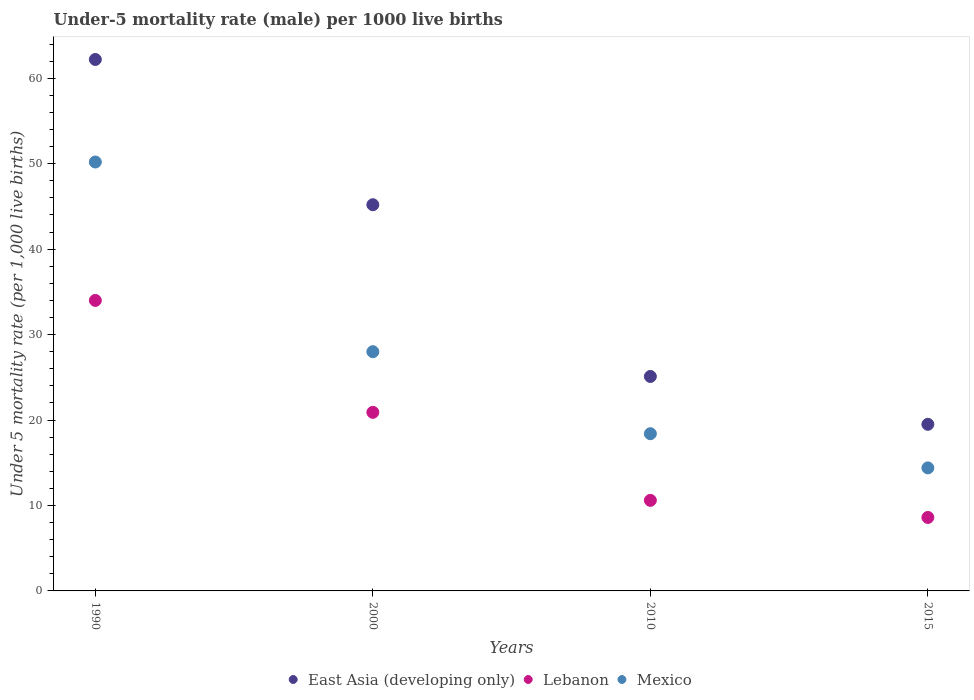Across all years, what is the maximum under-five mortality rate in Mexico?
Your answer should be compact. 50.2. Across all years, what is the minimum under-five mortality rate in Mexico?
Offer a terse response. 14.4. In which year was the under-five mortality rate in Lebanon minimum?
Ensure brevity in your answer.  2015. What is the total under-five mortality rate in Lebanon in the graph?
Keep it short and to the point. 74.1. What is the difference between the under-five mortality rate in East Asia (developing only) in 1990 and that in 2010?
Your answer should be very brief. 37.1. What is the difference between the under-five mortality rate in Mexico in 2000 and the under-five mortality rate in Lebanon in 2010?
Provide a short and direct response. 17.4. What is the average under-five mortality rate in Lebanon per year?
Make the answer very short. 18.52. In the year 2015, what is the difference between the under-five mortality rate in Mexico and under-five mortality rate in Lebanon?
Offer a terse response. 5.8. In how many years, is the under-five mortality rate in Lebanon greater than 56?
Give a very brief answer. 0. What is the ratio of the under-five mortality rate in Lebanon in 1990 to that in 2015?
Give a very brief answer. 3.95. Is the under-five mortality rate in Lebanon in 2000 less than that in 2015?
Keep it short and to the point. No. What is the difference between the highest and the second highest under-five mortality rate in East Asia (developing only)?
Your answer should be very brief. 17. What is the difference between the highest and the lowest under-five mortality rate in East Asia (developing only)?
Provide a short and direct response. 42.7. Is it the case that in every year, the sum of the under-five mortality rate in Lebanon and under-five mortality rate in Mexico  is greater than the under-five mortality rate in East Asia (developing only)?
Your answer should be very brief. Yes. What is the difference between two consecutive major ticks on the Y-axis?
Your answer should be compact. 10. Are the values on the major ticks of Y-axis written in scientific E-notation?
Give a very brief answer. No. Does the graph contain grids?
Keep it short and to the point. No. How many legend labels are there?
Make the answer very short. 3. What is the title of the graph?
Your answer should be very brief. Under-5 mortality rate (male) per 1000 live births. What is the label or title of the Y-axis?
Offer a terse response. Under 5 mortality rate (per 1,0 live births). What is the Under 5 mortality rate (per 1,000 live births) of East Asia (developing only) in 1990?
Make the answer very short. 62.2. What is the Under 5 mortality rate (per 1,000 live births) in Lebanon in 1990?
Your response must be concise. 34. What is the Under 5 mortality rate (per 1,000 live births) in Mexico in 1990?
Offer a very short reply. 50.2. What is the Under 5 mortality rate (per 1,000 live births) of East Asia (developing only) in 2000?
Offer a terse response. 45.2. What is the Under 5 mortality rate (per 1,000 live births) in Lebanon in 2000?
Offer a very short reply. 20.9. What is the Under 5 mortality rate (per 1,000 live births) in Mexico in 2000?
Make the answer very short. 28. What is the Under 5 mortality rate (per 1,000 live births) of East Asia (developing only) in 2010?
Your answer should be very brief. 25.1. What is the Under 5 mortality rate (per 1,000 live births) of Lebanon in 2010?
Your answer should be very brief. 10.6. What is the Under 5 mortality rate (per 1,000 live births) in Lebanon in 2015?
Your answer should be compact. 8.6. Across all years, what is the maximum Under 5 mortality rate (per 1,000 live births) in East Asia (developing only)?
Your response must be concise. 62.2. Across all years, what is the maximum Under 5 mortality rate (per 1,000 live births) in Lebanon?
Offer a terse response. 34. Across all years, what is the maximum Under 5 mortality rate (per 1,000 live births) of Mexico?
Your answer should be very brief. 50.2. Across all years, what is the minimum Under 5 mortality rate (per 1,000 live births) in East Asia (developing only)?
Your answer should be compact. 19.5. Across all years, what is the minimum Under 5 mortality rate (per 1,000 live births) of Lebanon?
Your answer should be compact. 8.6. What is the total Under 5 mortality rate (per 1,000 live births) of East Asia (developing only) in the graph?
Your answer should be compact. 152. What is the total Under 5 mortality rate (per 1,000 live births) in Lebanon in the graph?
Ensure brevity in your answer.  74.1. What is the total Under 5 mortality rate (per 1,000 live births) of Mexico in the graph?
Your answer should be very brief. 111. What is the difference between the Under 5 mortality rate (per 1,000 live births) of East Asia (developing only) in 1990 and that in 2000?
Offer a terse response. 17. What is the difference between the Under 5 mortality rate (per 1,000 live births) in Lebanon in 1990 and that in 2000?
Give a very brief answer. 13.1. What is the difference between the Under 5 mortality rate (per 1,000 live births) of East Asia (developing only) in 1990 and that in 2010?
Make the answer very short. 37.1. What is the difference between the Under 5 mortality rate (per 1,000 live births) of Lebanon in 1990 and that in 2010?
Your response must be concise. 23.4. What is the difference between the Under 5 mortality rate (per 1,000 live births) in Mexico in 1990 and that in 2010?
Your answer should be very brief. 31.8. What is the difference between the Under 5 mortality rate (per 1,000 live births) in East Asia (developing only) in 1990 and that in 2015?
Offer a terse response. 42.7. What is the difference between the Under 5 mortality rate (per 1,000 live births) of Lebanon in 1990 and that in 2015?
Provide a succinct answer. 25.4. What is the difference between the Under 5 mortality rate (per 1,000 live births) in Mexico in 1990 and that in 2015?
Ensure brevity in your answer.  35.8. What is the difference between the Under 5 mortality rate (per 1,000 live births) in East Asia (developing only) in 2000 and that in 2010?
Ensure brevity in your answer.  20.1. What is the difference between the Under 5 mortality rate (per 1,000 live births) in East Asia (developing only) in 2000 and that in 2015?
Offer a very short reply. 25.7. What is the difference between the Under 5 mortality rate (per 1,000 live births) of East Asia (developing only) in 2010 and that in 2015?
Give a very brief answer. 5.6. What is the difference between the Under 5 mortality rate (per 1,000 live births) in Lebanon in 2010 and that in 2015?
Your answer should be very brief. 2. What is the difference between the Under 5 mortality rate (per 1,000 live births) in Mexico in 2010 and that in 2015?
Offer a terse response. 4. What is the difference between the Under 5 mortality rate (per 1,000 live births) of East Asia (developing only) in 1990 and the Under 5 mortality rate (per 1,000 live births) of Lebanon in 2000?
Provide a short and direct response. 41.3. What is the difference between the Under 5 mortality rate (per 1,000 live births) in East Asia (developing only) in 1990 and the Under 5 mortality rate (per 1,000 live births) in Mexico in 2000?
Offer a terse response. 34.2. What is the difference between the Under 5 mortality rate (per 1,000 live births) in East Asia (developing only) in 1990 and the Under 5 mortality rate (per 1,000 live births) in Lebanon in 2010?
Ensure brevity in your answer.  51.6. What is the difference between the Under 5 mortality rate (per 1,000 live births) of East Asia (developing only) in 1990 and the Under 5 mortality rate (per 1,000 live births) of Mexico in 2010?
Keep it short and to the point. 43.8. What is the difference between the Under 5 mortality rate (per 1,000 live births) of East Asia (developing only) in 1990 and the Under 5 mortality rate (per 1,000 live births) of Lebanon in 2015?
Your answer should be compact. 53.6. What is the difference between the Under 5 mortality rate (per 1,000 live births) of East Asia (developing only) in 1990 and the Under 5 mortality rate (per 1,000 live births) of Mexico in 2015?
Your response must be concise. 47.8. What is the difference between the Under 5 mortality rate (per 1,000 live births) in Lebanon in 1990 and the Under 5 mortality rate (per 1,000 live births) in Mexico in 2015?
Your response must be concise. 19.6. What is the difference between the Under 5 mortality rate (per 1,000 live births) in East Asia (developing only) in 2000 and the Under 5 mortality rate (per 1,000 live births) in Lebanon in 2010?
Your answer should be very brief. 34.6. What is the difference between the Under 5 mortality rate (per 1,000 live births) of East Asia (developing only) in 2000 and the Under 5 mortality rate (per 1,000 live births) of Mexico in 2010?
Keep it short and to the point. 26.8. What is the difference between the Under 5 mortality rate (per 1,000 live births) in Lebanon in 2000 and the Under 5 mortality rate (per 1,000 live births) in Mexico in 2010?
Your answer should be compact. 2.5. What is the difference between the Under 5 mortality rate (per 1,000 live births) of East Asia (developing only) in 2000 and the Under 5 mortality rate (per 1,000 live births) of Lebanon in 2015?
Make the answer very short. 36.6. What is the difference between the Under 5 mortality rate (per 1,000 live births) in East Asia (developing only) in 2000 and the Under 5 mortality rate (per 1,000 live births) in Mexico in 2015?
Offer a terse response. 30.8. What is the average Under 5 mortality rate (per 1,000 live births) in East Asia (developing only) per year?
Provide a short and direct response. 38. What is the average Under 5 mortality rate (per 1,000 live births) in Lebanon per year?
Keep it short and to the point. 18.52. What is the average Under 5 mortality rate (per 1,000 live births) of Mexico per year?
Give a very brief answer. 27.75. In the year 1990, what is the difference between the Under 5 mortality rate (per 1,000 live births) in East Asia (developing only) and Under 5 mortality rate (per 1,000 live births) in Lebanon?
Your answer should be compact. 28.2. In the year 1990, what is the difference between the Under 5 mortality rate (per 1,000 live births) of East Asia (developing only) and Under 5 mortality rate (per 1,000 live births) of Mexico?
Make the answer very short. 12. In the year 1990, what is the difference between the Under 5 mortality rate (per 1,000 live births) of Lebanon and Under 5 mortality rate (per 1,000 live births) of Mexico?
Make the answer very short. -16.2. In the year 2000, what is the difference between the Under 5 mortality rate (per 1,000 live births) in East Asia (developing only) and Under 5 mortality rate (per 1,000 live births) in Lebanon?
Your response must be concise. 24.3. In the year 2010, what is the difference between the Under 5 mortality rate (per 1,000 live births) of East Asia (developing only) and Under 5 mortality rate (per 1,000 live births) of Lebanon?
Provide a short and direct response. 14.5. In the year 2010, what is the difference between the Under 5 mortality rate (per 1,000 live births) in East Asia (developing only) and Under 5 mortality rate (per 1,000 live births) in Mexico?
Your answer should be very brief. 6.7. In the year 2010, what is the difference between the Under 5 mortality rate (per 1,000 live births) in Lebanon and Under 5 mortality rate (per 1,000 live births) in Mexico?
Provide a short and direct response. -7.8. In the year 2015, what is the difference between the Under 5 mortality rate (per 1,000 live births) in East Asia (developing only) and Under 5 mortality rate (per 1,000 live births) in Mexico?
Make the answer very short. 5.1. What is the ratio of the Under 5 mortality rate (per 1,000 live births) of East Asia (developing only) in 1990 to that in 2000?
Offer a terse response. 1.38. What is the ratio of the Under 5 mortality rate (per 1,000 live births) in Lebanon in 1990 to that in 2000?
Keep it short and to the point. 1.63. What is the ratio of the Under 5 mortality rate (per 1,000 live births) in Mexico in 1990 to that in 2000?
Offer a terse response. 1.79. What is the ratio of the Under 5 mortality rate (per 1,000 live births) of East Asia (developing only) in 1990 to that in 2010?
Your answer should be compact. 2.48. What is the ratio of the Under 5 mortality rate (per 1,000 live births) in Lebanon in 1990 to that in 2010?
Ensure brevity in your answer.  3.21. What is the ratio of the Under 5 mortality rate (per 1,000 live births) in Mexico in 1990 to that in 2010?
Your answer should be compact. 2.73. What is the ratio of the Under 5 mortality rate (per 1,000 live births) of East Asia (developing only) in 1990 to that in 2015?
Your response must be concise. 3.19. What is the ratio of the Under 5 mortality rate (per 1,000 live births) of Lebanon in 1990 to that in 2015?
Your response must be concise. 3.95. What is the ratio of the Under 5 mortality rate (per 1,000 live births) in Mexico in 1990 to that in 2015?
Offer a very short reply. 3.49. What is the ratio of the Under 5 mortality rate (per 1,000 live births) in East Asia (developing only) in 2000 to that in 2010?
Make the answer very short. 1.8. What is the ratio of the Under 5 mortality rate (per 1,000 live births) of Lebanon in 2000 to that in 2010?
Your answer should be compact. 1.97. What is the ratio of the Under 5 mortality rate (per 1,000 live births) of Mexico in 2000 to that in 2010?
Offer a very short reply. 1.52. What is the ratio of the Under 5 mortality rate (per 1,000 live births) of East Asia (developing only) in 2000 to that in 2015?
Keep it short and to the point. 2.32. What is the ratio of the Under 5 mortality rate (per 1,000 live births) in Lebanon in 2000 to that in 2015?
Offer a terse response. 2.43. What is the ratio of the Under 5 mortality rate (per 1,000 live births) in Mexico in 2000 to that in 2015?
Ensure brevity in your answer.  1.94. What is the ratio of the Under 5 mortality rate (per 1,000 live births) in East Asia (developing only) in 2010 to that in 2015?
Your response must be concise. 1.29. What is the ratio of the Under 5 mortality rate (per 1,000 live births) in Lebanon in 2010 to that in 2015?
Provide a succinct answer. 1.23. What is the ratio of the Under 5 mortality rate (per 1,000 live births) of Mexico in 2010 to that in 2015?
Give a very brief answer. 1.28. What is the difference between the highest and the second highest Under 5 mortality rate (per 1,000 live births) in East Asia (developing only)?
Ensure brevity in your answer.  17. What is the difference between the highest and the lowest Under 5 mortality rate (per 1,000 live births) in East Asia (developing only)?
Your response must be concise. 42.7. What is the difference between the highest and the lowest Under 5 mortality rate (per 1,000 live births) in Lebanon?
Ensure brevity in your answer.  25.4. What is the difference between the highest and the lowest Under 5 mortality rate (per 1,000 live births) in Mexico?
Your answer should be compact. 35.8. 